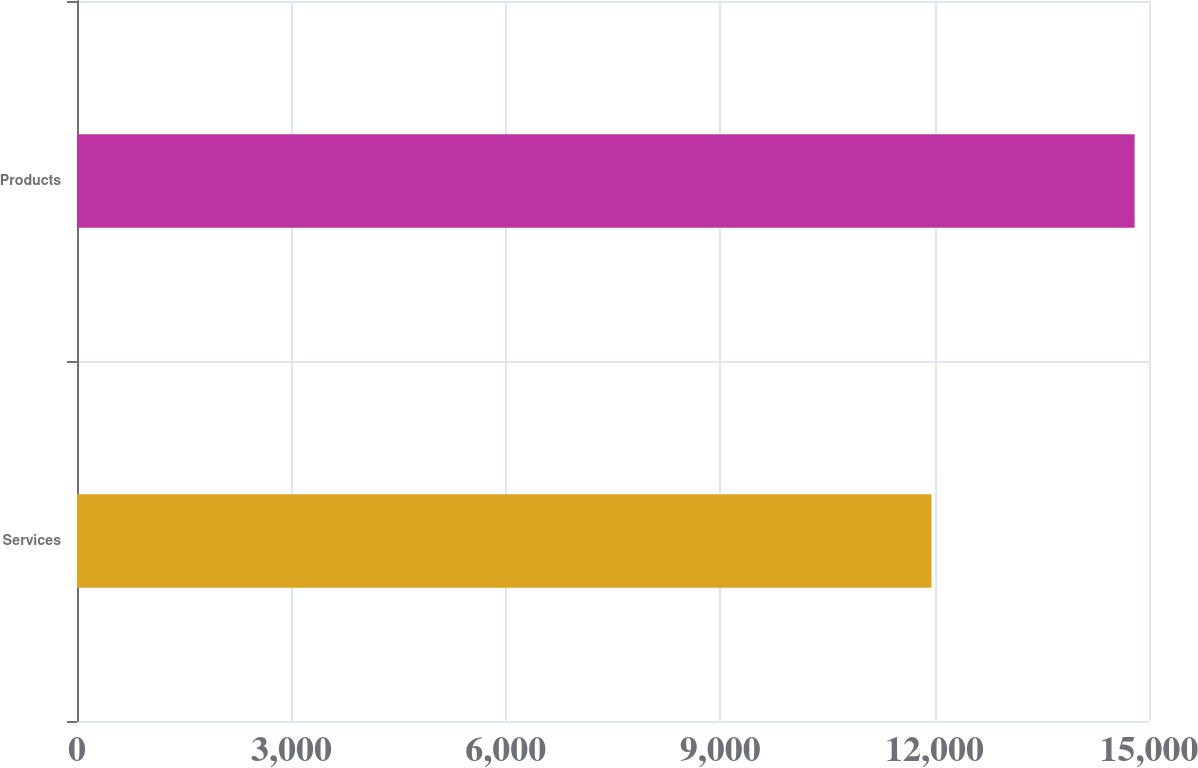Convert chart. <chart><loc_0><loc_0><loc_500><loc_500><bar_chart><fcel>Services<fcel>Products<nl><fcel>11957<fcel>14799<nl></chart> 